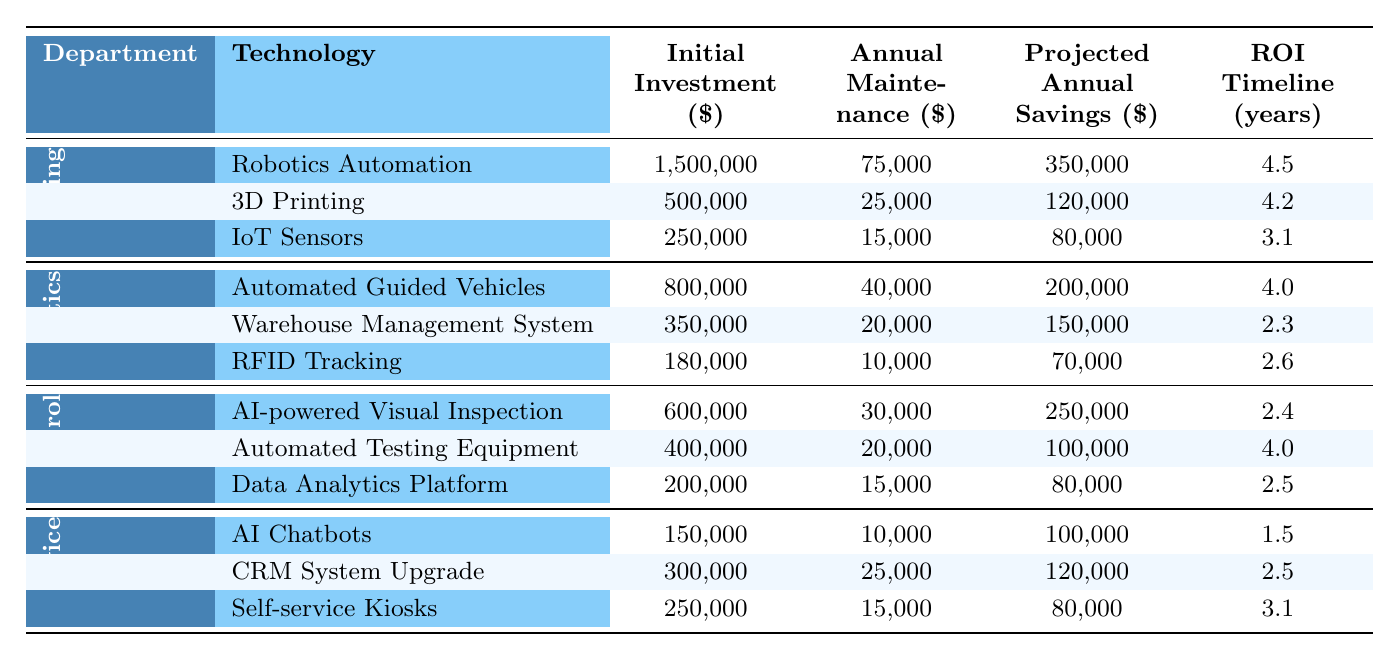What is the initial investment required for Robotics Automation? The table indicates that the initial investment for Robotics Automation under the Manufacturing department is $1,500,000.
Answer: 1,500,000 What is the projected annual savings for the Warehouse Management System? According to the table, the projected annual savings for the Warehouse Management System in the Logistics department is $150,000.
Answer: 150,000 Which technology in Quality Control has the longest ROI timeline? By comparing the ROI timelines of all technologies listed in the Quality Control section, AI-powered Visual Inspection has the longest ROI timeline of 2.4 years, which is longer than both Automated Testing Equipment (4 years) and Data Analytics Platform (2.5 years).
Answer: Automated Testing Equipment What is the total initial investment for all technologies in Customer Service? The initial investments for Customer Service technologies are $150,000 (AI Chatbots), $300,000 (CRM System Upgrade), and $250,000 (Self-service Kiosks). Summing these values: 150,000 + 300,000 + 250,000 = 700,000.
Answer: 700,000 Is the annual maintenance cost of 3D Printing higher than that of IoT Sensors? The table shows that the Annual Maintenance cost for 3D Printing is $25,000 while for IoT Sensors it is $15,000. Since $25,000 is greater than $15,000, the statement is true.
Answer: Yes What technology in Logistics has the highest projected annual savings, and what is the amount? Looking at the projected savings in the Logistics section, the Automated Guided Vehicles have a projected annual savings of $200,000, which is the highest compared to Warehouse Management System ($150,000) and RFID Tracking ($70,000).
Answer: Automated Guided Vehicles, 200,000 If we average the ROI timelines of all technologies in Quality Control, what is the result? The ROI timelines are 2.4 (AI-powered Visual Inspection), 4.0 (Automated Testing Equipment), and 2.5 (Data Analytics Platform). The average is calculated by (2.4 + 4.0 + 2.5) / 3 = 8.9 / 3 = 2.97.
Answer: 2.97 What is the difference in projected annual savings between Robotics Automation and IoT Sensors? The projected annual savings for Robotics Automation is $350,000, and for IoT Sensors, it is $80,000. The difference is $350,000 - $80,000 = $270,000.
Answer: 270,000 Has the annual maintenance cost for Automated Guided Vehicles increased or decreased compared to the Warehouse Management System? The annual maintenance for Automated Guided Vehicles is $40,000, while for Warehouse Management System it is $20,000. Since $40,000 is higher than $20,000, it has increased.
Answer: Increased Which department has the technology with the lowest initial investment, and what is that investment? The lowest initial investment is in the RFID Tracking technology under Logistics, which costs $180,000.
Answer: Logistics, 180,000 